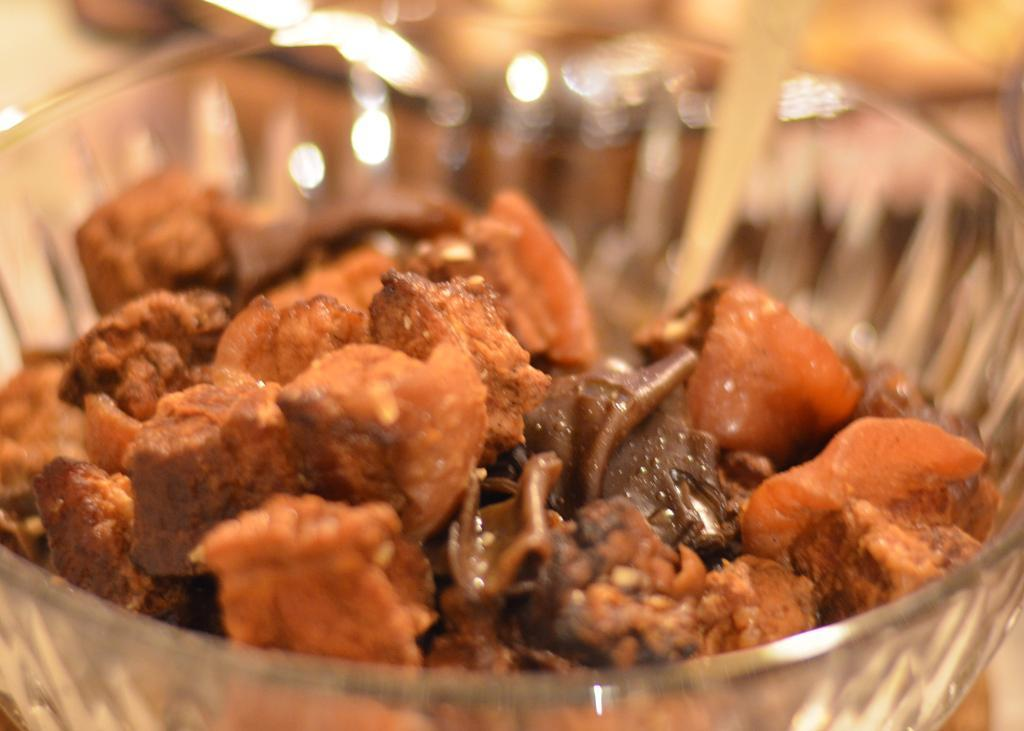What is present in the image? There is a bowl in the image. What is inside the bowl? The bowl contains a food item. How many trucks are parked next to the bowl in the image? There are no trucks present in the image. What type of plant is growing inside the bowl? There is no plant growing inside the bowl; it contains a food item. 